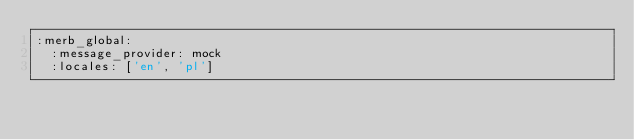Convert code to text. <code><loc_0><loc_0><loc_500><loc_500><_YAML_>:merb_global:
  :message_provider: mock
  :locales: ['en', 'pl']
</code> 